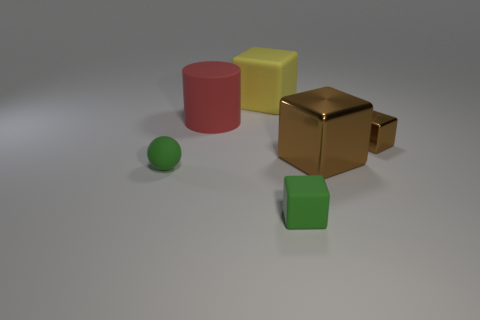Subtract all brown cubes. How many were subtracted if there are1brown cubes left? 1 Add 4 purple things. How many objects exist? 10 Subtract all large brown shiny blocks. How many blocks are left? 3 Add 6 small brown blocks. How many small brown blocks are left? 7 Add 2 large purple shiny spheres. How many large purple shiny spheres exist? 2 Subtract all yellow cubes. How many cubes are left? 3 Subtract 0 blue cylinders. How many objects are left? 6 Subtract all cylinders. How many objects are left? 5 Subtract 1 blocks. How many blocks are left? 3 Subtract all yellow cylinders. Subtract all brown spheres. How many cylinders are left? 1 